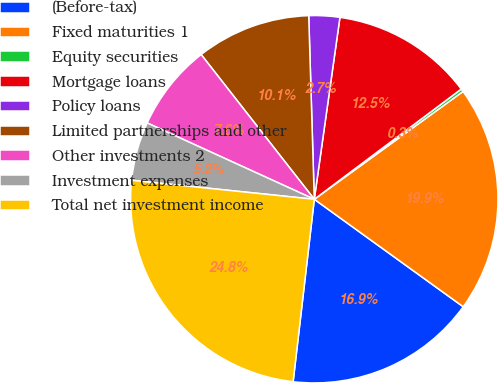Convert chart to OTSL. <chart><loc_0><loc_0><loc_500><loc_500><pie_chart><fcel>(Before-tax)<fcel>Fixed maturities 1<fcel>Equity securities<fcel>Mortgage loans<fcel>Policy loans<fcel>Limited partnerships and other<fcel>Other investments 2<fcel>Investment expenses<fcel>Total net investment income<nl><fcel>16.89%<fcel>19.93%<fcel>0.26%<fcel>12.53%<fcel>2.71%<fcel>10.08%<fcel>7.62%<fcel>5.17%<fcel>24.81%<nl></chart> 